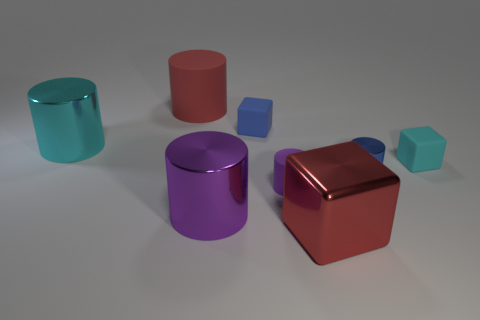Add 1 big gray rubber cubes. How many objects exist? 9 Subtract all small shiny cylinders. How many cylinders are left? 4 Subtract all red cylinders. How many cylinders are left? 4 Subtract all cylinders. How many objects are left? 3 Subtract 3 cylinders. How many cylinders are left? 2 Subtract all blue blocks. Subtract all blue cylinders. How many blocks are left? 2 Subtract all purple balls. How many red cylinders are left? 1 Subtract all small blue cylinders. Subtract all red matte things. How many objects are left? 6 Add 2 big shiny things. How many big shiny things are left? 5 Add 5 tiny red objects. How many tiny red objects exist? 5 